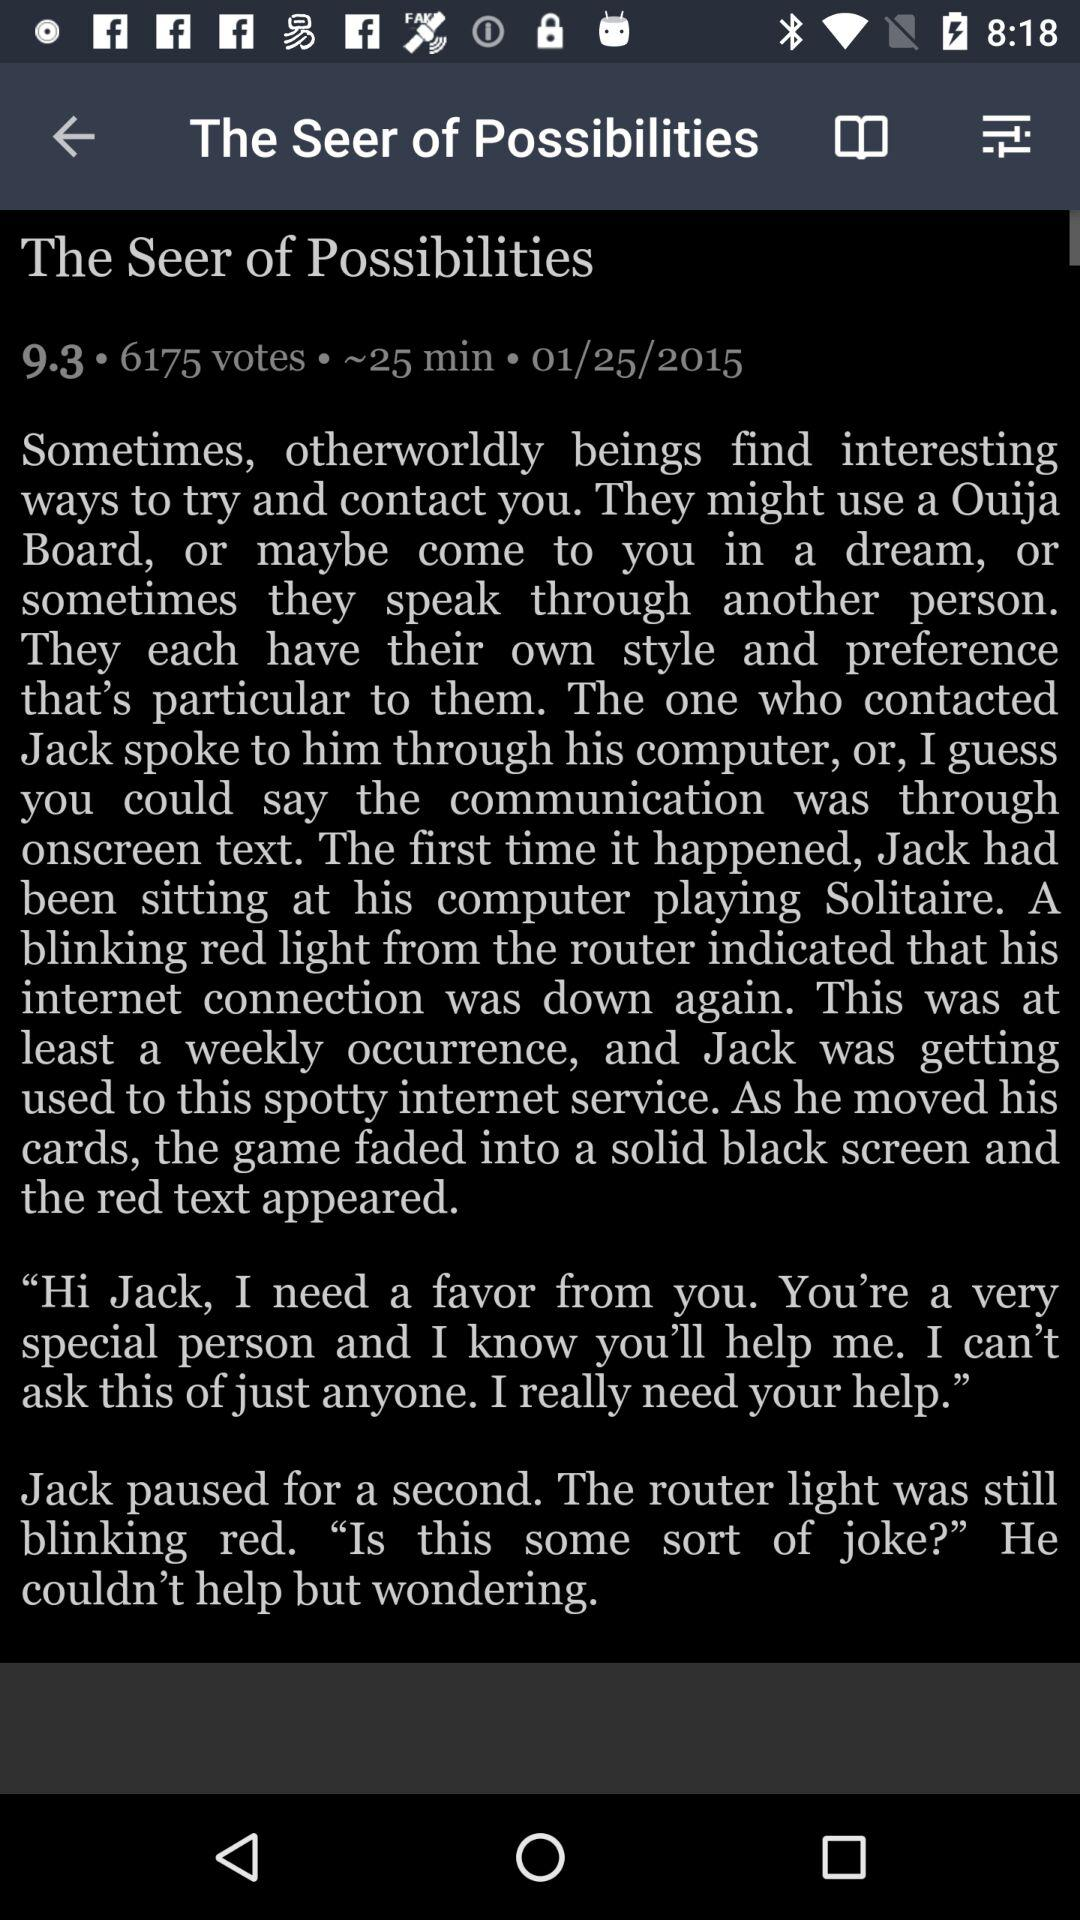What's the publication date of the article? The publication date of the article is January 25, 2015. 